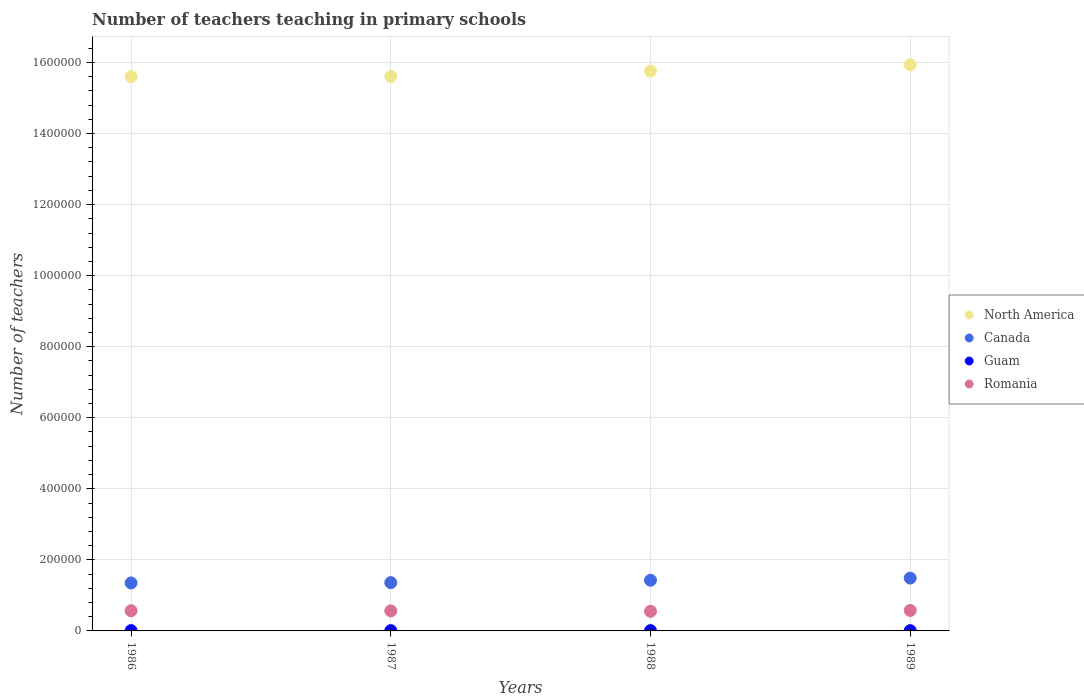What is the number of teachers teaching in primary schools in North America in 1987?
Provide a succinct answer. 1.56e+06. Across all years, what is the maximum number of teachers teaching in primary schools in North America?
Ensure brevity in your answer.  1.59e+06. Across all years, what is the minimum number of teachers teaching in primary schools in North America?
Provide a succinct answer. 1.56e+06. In which year was the number of teachers teaching in primary schools in Romania minimum?
Your answer should be compact. 1988. What is the total number of teachers teaching in primary schools in Romania in the graph?
Your response must be concise. 2.26e+05. What is the difference between the number of teachers teaching in primary schools in Romania in 1987 and that in 1988?
Offer a very short reply. 1111. What is the difference between the number of teachers teaching in primary schools in Romania in 1989 and the number of teachers teaching in primary schools in Canada in 1986?
Your response must be concise. -7.74e+04. What is the average number of teachers teaching in primary schools in Guam per year?
Your response must be concise. 822.5. In the year 1989, what is the difference between the number of teachers teaching in primary schools in North America and number of teachers teaching in primary schools in Canada?
Provide a succinct answer. 1.44e+06. In how many years, is the number of teachers teaching in primary schools in Canada greater than 1560000?
Keep it short and to the point. 0. What is the ratio of the number of teachers teaching in primary schools in North America in 1987 to that in 1989?
Provide a succinct answer. 0.98. Is the number of teachers teaching in primary schools in Romania in 1987 less than that in 1988?
Keep it short and to the point. No. What is the difference between the highest and the lowest number of teachers teaching in primary schools in Romania?
Ensure brevity in your answer.  2359. In how many years, is the number of teachers teaching in primary schools in Canada greater than the average number of teachers teaching in primary schools in Canada taken over all years?
Provide a short and direct response. 2. Is the sum of the number of teachers teaching in primary schools in Romania in 1986 and 1987 greater than the maximum number of teachers teaching in primary schools in North America across all years?
Your answer should be compact. No. Is it the case that in every year, the sum of the number of teachers teaching in primary schools in Romania and number of teachers teaching in primary schools in North America  is greater than the sum of number of teachers teaching in primary schools in Guam and number of teachers teaching in primary schools in Canada?
Make the answer very short. Yes. Is it the case that in every year, the sum of the number of teachers teaching in primary schools in Canada and number of teachers teaching in primary schools in Guam  is greater than the number of teachers teaching in primary schools in Romania?
Offer a very short reply. Yes. Is the number of teachers teaching in primary schools in Romania strictly greater than the number of teachers teaching in primary schools in Canada over the years?
Offer a terse response. No. How many dotlines are there?
Your answer should be compact. 4. How many years are there in the graph?
Offer a very short reply. 4. What is the difference between two consecutive major ticks on the Y-axis?
Your answer should be compact. 2.00e+05. Does the graph contain any zero values?
Keep it short and to the point. No. How many legend labels are there?
Your answer should be compact. 4. What is the title of the graph?
Ensure brevity in your answer.  Number of teachers teaching in primary schools. What is the label or title of the Y-axis?
Make the answer very short. Number of teachers. What is the Number of teachers in North America in 1986?
Provide a succinct answer. 1.56e+06. What is the Number of teachers of Canada in 1986?
Make the answer very short. 1.35e+05. What is the Number of teachers of Guam in 1986?
Provide a short and direct response. 840. What is the Number of teachers of Romania in 1986?
Offer a very short reply. 5.69e+04. What is the Number of teachers of North America in 1987?
Provide a succinct answer. 1.56e+06. What is the Number of teachers of Canada in 1987?
Make the answer very short. 1.36e+05. What is the Number of teachers in Guam in 1987?
Your answer should be very brief. 840. What is the Number of teachers of Romania in 1987?
Ensure brevity in your answer.  5.63e+04. What is the Number of teachers in North America in 1988?
Give a very brief answer. 1.58e+06. What is the Number of teachers in Canada in 1988?
Provide a short and direct response. 1.43e+05. What is the Number of teachers of Guam in 1988?
Offer a terse response. 835. What is the Number of teachers of Romania in 1988?
Provide a short and direct response. 5.52e+04. What is the Number of teachers of North America in 1989?
Offer a very short reply. 1.59e+06. What is the Number of teachers of Canada in 1989?
Provide a short and direct response. 1.49e+05. What is the Number of teachers in Guam in 1989?
Your answer should be compact. 775. What is the Number of teachers in Romania in 1989?
Give a very brief answer. 5.76e+04. Across all years, what is the maximum Number of teachers in North America?
Offer a very short reply. 1.59e+06. Across all years, what is the maximum Number of teachers in Canada?
Provide a short and direct response. 1.49e+05. Across all years, what is the maximum Number of teachers of Guam?
Make the answer very short. 840. Across all years, what is the maximum Number of teachers of Romania?
Offer a terse response. 5.76e+04. Across all years, what is the minimum Number of teachers of North America?
Your response must be concise. 1.56e+06. Across all years, what is the minimum Number of teachers of Canada?
Keep it short and to the point. 1.35e+05. Across all years, what is the minimum Number of teachers of Guam?
Ensure brevity in your answer.  775. Across all years, what is the minimum Number of teachers in Romania?
Your answer should be compact. 5.52e+04. What is the total Number of teachers of North America in the graph?
Provide a short and direct response. 6.29e+06. What is the total Number of teachers in Canada in the graph?
Your answer should be compact. 5.62e+05. What is the total Number of teachers of Guam in the graph?
Give a very brief answer. 3290. What is the total Number of teachers of Romania in the graph?
Give a very brief answer. 2.26e+05. What is the difference between the Number of teachers of North America in 1986 and that in 1987?
Provide a succinct answer. -322.12. What is the difference between the Number of teachers in Canada in 1986 and that in 1987?
Provide a short and direct response. -880. What is the difference between the Number of teachers in Guam in 1986 and that in 1987?
Your answer should be compact. 0. What is the difference between the Number of teachers of Romania in 1986 and that in 1987?
Offer a terse response. 558. What is the difference between the Number of teachers in North America in 1986 and that in 1988?
Your answer should be compact. -1.55e+04. What is the difference between the Number of teachers in Canada in 1986 and that in 1988?
Make the answer very short. -7695. What is the difference between the Number of teachers of Romania in 1986 and that in 1988?
Give a very brief answer. 1669. What is the difference between the Number of teachers of North America in 1986 and that in 1989?
Keep it short and to the point. -3.30e+04. What is the difference between the Number of teachers of Canada in 1986 and that in 1989?
Make the answer very short. -1.37e+04. What is the difference between the Number of teachers in Romania in 1986 and that in 1989?
Provide a succinct answer. -690. What is the difference between the Number of teachers of North America in 1987 and that in 1988?
Your answer should be compact. -1.52e+04. What is the difference between the Number of teachers of Canada in 1987 and that in 1988?
Ensure brevity in your answer.  -6815. What is the difference between the Number of teachers in Guam in 1987 and that in 1988?
Make the answer very short. 5. What is the difference between the Number of teachers of Romania in 1987 and that in 1988?
Ensure brevity in your answer.  1111. What is the difference between the Number of teachers of North America in 1987 and that in 1989?
Offer a terse response. -3.27e+04. What is the difference between the Number of teachers of Canada in 1987 and that in 1989?
Your response must be concise. -1.28e+04. What is the difference between the Number of teachers in Romania in 1987 and that in 1989?
Your response must be concise. -1248. What is the difference between the Number of teachers of North America in 1988 and that in 1989?
Make the answer very short. -1.75e+04. What is the difference between the Number of teachers in Canada in 1988 and that in 1989?
Provide a succinct answer. -5965. What is the difference between the Number of teachers of Romania in 1988 and that in 1989?
Your response must be concise. -2359. What is the difference between the Number of teachers in North America in 1986 and the Number of teachers in Canada in 1987?
Make the answer very short. 1.42e+06. What is the difference between the Number of teachers of North America in 1986 and the Number of teachers of Guam in 1987?
Provide a succinct answer. 1.56e+06. What is the difference between the Number of teachers of North America in 1986 and the Number of teachers of Romania in 1987?
Your response must be concise. 1.50e+06. What is the difference between the Number of teachers of Canada in 1986 and the Number of teachers of Guam in 1987?
Offer a very short reply. 1.34e+05. What is the difference between the Number of teachers of Canada in 1986 and the Number of teachers of Romania in 1987?
Your answer should be very brief. 7.87e+04. What is the difference between the Number of teachers of Guam in 1986 and the Number of teachers of Romania in 1987?
Your response must be concise. -5.55e+04. What is the difference between the Number of teachers in North America in 1986 and the Number of teachers in Canada in 1988?
Make the answer very short. 1.42e+06. What is the difference between the Number of teachers in North America in 1986 and the Number of teachers in Guam in 1988?
Provide a short and direct response. 1.56e+06. What is the difference between the Number of teachers of North America in 1986 and the Number of teachers of Romania in 1988?
Your answer should be very brief. 1.51e+06. What is the difference between the Number of teachers in Canada in 1986 and the Number of teachers in Guam in 1988?
Keep it short and to the point. 1.34e+05. What is the difference between the Number of teachers of Canada in 1986 and the Number of teachers of Romania in 1988?
Provide a succinct answer. 7.98e+04. What is the difference between the Number of teachers of Guam in 1986 and the Number of teachers of Romania in 1988?
Your answer should be compact. -5.44e+04. What is the difference between the Number of teachers in North America in 1986 and the Number of teachers in Canada in 1989?
Provide a succinct answer. 1.41e+06. What is the difference between the Number of teachers in North America in 1986 and the Number of teachers in Guam in 1989?
Ensure brevity in your answer.  1.56e+06. What is the difference between the Number of teachers of North America in 1986 and the Number of teachers of Romania in 1989?
Make the answer very short. 1.50e+06. What is the difference between the Number of teachers of Canada in 1986 and the Number of teachers of Guam in 1989?
Your answer should be very brief. 1.34e+05. What is the difference between the Number of teachers in Canada in 1986 and the Number of teachers in Romania in 1989?
Make the answer very short. 7.74e+04. What is the difference between the Number of teachers of Guam in 1986 and the Number of teachers of Romania in 1989?
Make the answer very short. -5.67e+04. What is the difference between the Number of teachers in North America in 1987 and the Number of teachers in Canada in 1988?
Offer a terse response. 1.42e+06. What is the difference between the Number of teachers of North America in 1987 and the Number of teachers of Guam in 1988?
Your answer should be compact. 1.56e+06. What is the difference between the Number of teachers of North America in 1987 and the Number of teachers of Romania in 1988?
Provide a short and direct response. 1.51e+06. What is the difference between the Number of teachers in Canada in 1987 and the Number of teachers in Guam in 1988?
Your answer should be very brief. 1.35e+05. What is the difference between the Number of teachers of Canada in 1987 and the Number of teachers of Romania in 1988?
Your response must be concise. 8.07e+04. What is the difference between the Number of teachers of Guam in 1987 and the Number of teachers of Romania in 1988?
Give a very brief answer. -5.44e+04. What is the difference between the Number of teachers of North America in 1987 and the Number of teachers of Canada in 1989?
Give a very brief answer. 1.41e+06. What is the difference between the Number of teachers in North America in 1987 and the Number of teachers in Guam in 1989?
Keep it short and to the point. 1.56e+06. What is the difference between the Number of teachers in North America in 1987 and the Number of teachers in Romania in 1989?
Offer a terse response. 1.50e+06. What is the difference between the Number of teachers of Canada in 1987 and the Number of teachers of Guam in 1989?
Give a very brief answer. 1.35e+05. What is the difference between the Number of teachers of Canada in 1987 and the Number of teachers of Romania in 1989?
Your answer should be very brief. 7.83e+04. What is the difference between the Number of teachers in Guam in 1987 and the Number of teachers in Romania in 1989?
Provide a short and direct response. -5.67e+04. What is the difference between the Number of teachers in North America in 1988 and the Number of teachers in Canada in 1989?
Your response must be concise. 1.43e+06. What is the difference between the Number of teachers of North America in 1988 and the Number of teachers of Guam in 1989?
Your response must be concise. 1.58e+06. What is the difference between the Number of teachers of North America in 1988 and the Number of teachers of Romania in 1989?
Your answer should be compact. 1.52e+06. What is the difference between the Number of teachers of Canada in 1988 and the Number of teachers of Guam in 1989?
Ensure brevity in your answer.  1.42e+05. What is the difference between the Number of teachers in Canada in 1988 and the Number of teachers in Romania in 1989?
Offer a terse response. 8.51e+04. What is the difference between the Number of teachers of Guam in 1988 and the Number of teachers of Romania in 1989?
Provide a short and direct response. -5.67e+04. What is the average Number of teachers in North America per year?
Offer a terse response. 1.57e+06. What is the average Number of teachers in Canada per year?
Give a very brief answer. 1.41e+05. What is the average Number of teachers of Guam per year?
Offer a terse response. 822.5. What is the average Number of teachers of Romania per year?
Ensure brevity in your answer.  5.65e+04. In the year 1986, what is the difference between the Number of teachers in North America and Number of teachers in Canada?
Offer a terse response. 1.43e+06. In the year 1986, what is the difference between the Number of teachers in North America and Number of teachers in Guam?
Ensure brevity in your answer.  1.56e+06. In the year 1986, what is the difference between the Number of teachers in North America and Number of teachers in Romania?
Provide a succinct answer. 1.50e+06. In the year 1986, what is the difference between the Number of teachers of Canada and Number of teachers of Guam?
Provide a succinct answer. 1.34e+05. In the year 1986, what is the difference between the Number of teachers in Canada and Number of teachers in Romania?
Offer a terse response. 7.81e+04. In the year 1986, what is the difference between the Number of teachers in Guam and Number of teachers in Romania?
Keep it short and to the point. -5.60e+04. In the year 1987, what is the difference between the Number of teachers in North America and Number of teachers in Canada?
Give a very brief answer. 1.42e+06. In the year 1987, what is the difference between the Number of teachers of North America and Number of teachers of Guam?
Your answer should be compact. 1.56e+06. In the year 1987, what is the difference between the Number of teachers in North America and Number of teachers in Romania?
Offer a very short reply. 1.50e+06. In the year 1987, what is the difference between the Number of teachers in Canada and Number of teachers in Guam?
Your answer should be very brief. 1.35e+05. In the year 1987, what is the difference between the Number of teachers of Canada and Number of teachers of Romania?
Give a very brief answer. 7.96e+04. In the year 1987, what is the difference between the Number of teachers in Guam and Number of teachers in Romania?
Keep it short and to the point. -5.55e+04. In the year 1988, what is the difference between the Number of teachers in North America and Number of teachers in Canada?
Keep it short and to the point. 1.43e+06. In the year 1988, what is the difference between the Number of teachers of North America and Number of teachers of Guam?
Your response must be concise. 1.58e+06. In the year 1988, what is the difference between the Number of teachers of North America and Number of teachers of Romania?
Offer a very short reply. 1.52e+06. In the year 1988, what is the difference between the Number of teachers of Canada and Number of teachers of Guam?
Offer a terse response. 1.42e+05. In the year 1988, what is the difference between the Number of teachers in Canada and Number of teachers in Romania?
Your answer should be very brief. 8.75e+04. In the year 1988, what is the difference between the Number of teachers of Guam and Number of teachers of Romania?
Your answer should be compact. -5.44e+04. In the year 1989, what is the difference between the Number of teachers in North America and Number of teachers in Canada?
Keep it short and to the point. 1.44e+06. In the year 1989, what is the difference between the Number of teachers in North America and Number of teachers in Guam?
Your answer should be compact. 1.59e+06. In the year 1989, what is the difference between the Number of teachers of North America and Number of teachers of Romania?
Provide a succinct answer. 1.54e+06. In the year 1989, what is the difference between the Number of teachers of Canada and Number of teachers of Guam?
Offer a terse response. 1.48e+05. In the year 1989, what is the difference between the Number of teachers of Canada and Number of teachers of Romania?
Ensure brevity in your answer.  9.11e+04. In the year 1989, what is the difference between the Number of teachers of Guam and Number of teachers of Romania?
Provide a succinct answer. -5.68e+04. What is the ratio of the Number of teachers of Guam in 1986 to that in 1987?
Give a very brief answer. 1. What is the ratio of the Number of teachers in Romania in 1986 to that in 1987?
Your response must be concise. 1.01. What is the ratio of the Number of teachers in North America in 1986 to that in 1988?
Your answer should be compact. 0.99. What is the ratio of the Number of teachers of Canada in 1986 to that in 1988?
Your answer should be compact. 0.95. What is the ratio of the Number of teachers in Romania in 1986 to that in 1988?
Offer a terse response. 1.03. What is the ratio of the Number of teachers in North America in 1986 to that in 1989?
Offer a terse response. 0.98. What is the ratio of the Number of teachers of Canada in 1986 to that in 1989?
Give a very brief answer. 0.91. What is the ratio of the Number of teachers in Guam in 1986 to that in 1989?
Offer a terse response. 1.08. What is the ratio of the Number of teachers of Canada in 1987 to that in 1988?
Offer a very short reply. 0.95. What is the ratio of the Number of teachers of Guam in 1987 to that in 1988?
Make the answer very short. 1.01. What is the ratio of the Number of teachers of Romania in 1987 to that in 1988?
Your response must be concise. 1.02. What is the ratio of the Number of teachers in North America in 1987 to that in 1989?
Ensure brevity in your answer.  0.98. What is the ratio of the Number of teachers of Canada in 1987 to that in 1989?
Provide a short and direct response. 0.91. What is the ratio of the Number of teachers of Guam in 1987 to that in 1989?
Give a very brief answer. 1.08. What is the ratio of the Number of teachers in Romania in 1987 to that in 1989?
Provide a succinct answer. 0.98. What is the ratio of the Number of teachers of Canada in 1988 to that in 1989?
Offer a very short reply. 0.96. What is the ratio of the Number of teachers in Guam in 1988 to that in 1989?
Make the answer very short. 1.08. What is the difference between the highest and the second highest Number of teachers of North America?
Your answer should be compact. 1.75e+04. What is the difference between the highest and the second highest Number of teachers of Canada?
Your answer should be compact. 5965. What is the difference between the highest and the second highest Number of teachers in Romania?
Your answer should be compact. 690. What is the difference between the highest and the lowest Number of teachers in North America?
Offer a very short reply. 3.30e+04. What is the difference between the highest and the lowest Number of teachers in Canada?
Ensure brevity in your answer.  1.37e+04. What is the difference between the highest and the lowest Number of teachers in Guam?
Your answer should be very brief. 65. What is the difference between the highest and the lowest Number of teachers of Romania?
Offer a terse response. 2359. 